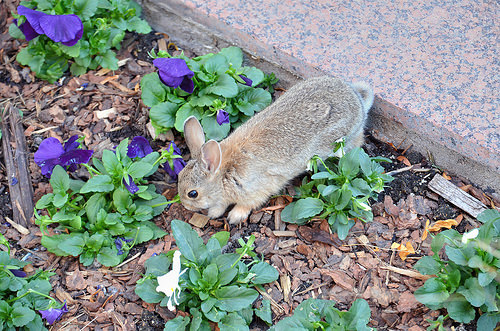<image>
Can you confirm if the rabbit is on the plant? Yes. Looking at the image, I can see the rabbit is positioned on top of the plant, with the plant providing support. Is there a flower under the rabbit? No. The flower is not positioned under the rabbit. The vertical relationship between these objects is different. Where is the rabbit in relation to the granite? Is it next to the granite? Yes. The rabbit is positioned adjacent to the granite, located nearby in the same general area. 